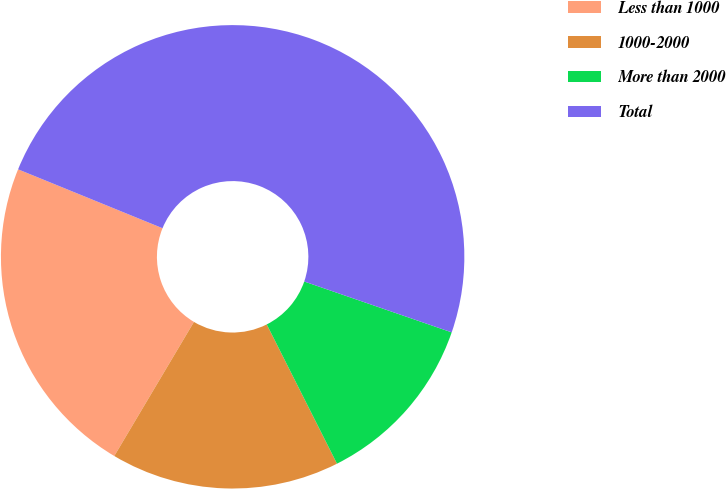Convert chart to OTSL. <chart><loc_0><loc_0><loc_500><loc_500><pie_chart><fcel>Less than 1000<fcel>1000-2000<fcel>More than 2000<fcel>Total<nl><fcel>22.63%<fcel>15.97%<fcel>12.28%<fcel>49.13%<nl></chart> 